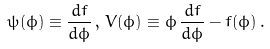Convert formula to latex. <formula><loc_0><loc_0><loc_500><loc_500>\psi ( \phi ) \equiv \frac { d f } { d \phi } \, , \, V ( \phi ) \equiv \phi \, \frac { d f } { d \phi } - f ( \phi ) \, .</formula> 